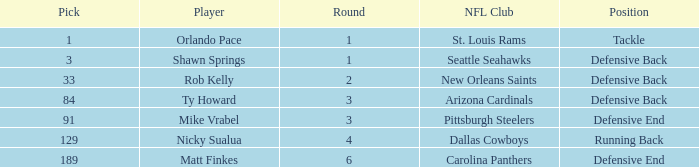What lowest round has orlando pace as the player? 1.0. 